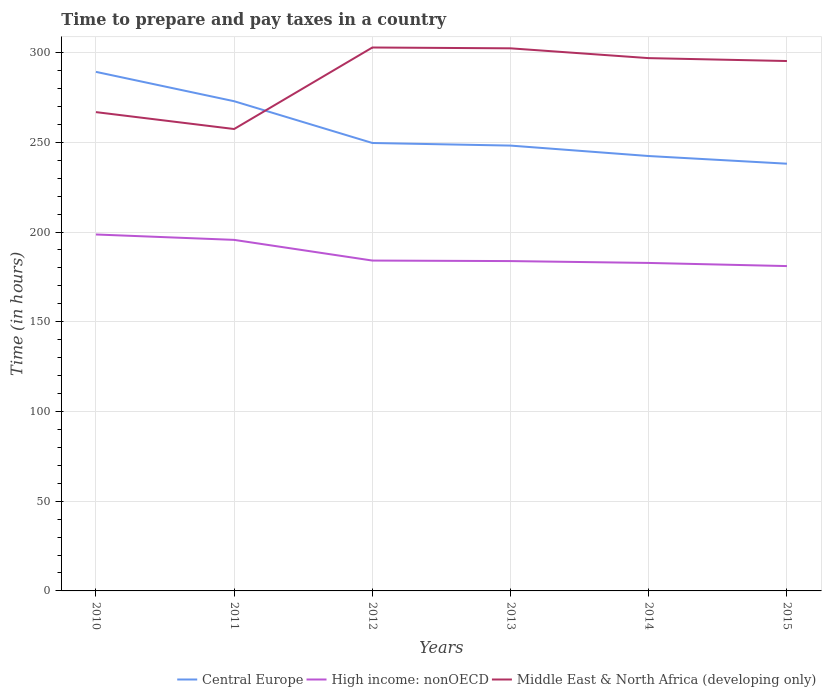How many different coloured lines are there?
Offer a terse response. 3. Across all years, what is the maximum number of hours required to prepare and pay taxes in Central Europe?
Make the answer very short. 238.09. In which year was the number of hours required to prepare and pay taxes in High income: nonOECD maximum?
Your response must be concise. 2015. What is the total number of hours required to prepare and pay taxes in Central Europe in the graph?
Ensure brevity in your answer.  51.18. What is the difference between the highest and the second highest number of hours required to prepare and pay taxes in Middle East & North Africa (developing only)?
Your answer should be compact. 45.43. What is the difference between the highest and the lowest number of hours required to prepare and pay taxes in Central Europe?
Provide a short and direct response. 2. Is the number of hours required to prepare and pay taxes in Central Europe strictly greater than the number of hours required to prepare and pay taxes in Middle East & North Africa (developing only) over the years?
Give a very brief answer. No. Are the values on the major ticks of Y-axis written in scientific E-notation?
Keep it short and to the point. No. Does the graph contain any zero values?
Provide a succinct answer. No. Does the graph contain grids?
Your answer should be compact. Yes. How many legend labels are there?
Make the answer very short. 3. What is the title of the graph?
Keep it short and to the point. Time to prepare and pay taxes in a country. What is the label or title of the Y-axis?
Keep it short and to the point. Time (in hours). What is the Time (in hours) of Central Europe in 2010?
Keep it short and to the point. 289.27. What is the Time (in hours) of High income: nonOECD in 2010?
Offer a terse response. 198.65. What is the Time (in hours) in Middle East & North Africa (developing only) in 2010?
Your response must be concise. 266.83. What is the Time (in hours) in Central Europe in 2011?
Your response must be concise. 272.91. What is the Time (in hours) in High income: nonOECD in 2011?
Ensure brevity in your answer.  195.63. What is the Time (in hours) of Middle East & North Africa (developing only) in 2011?
Offer a terse response. 257.42. What is the Time (in hours) of Central Europe in 2012?
Ensure brevity in your answer.  249.64. What is the Time (in hours) of High income: nonOECD in 2012?
Your answer should be compact. 184.11. What is the Time (in hours) in Middle East & North Africa (developing only) in 2012?
Ensure brevity in your answer.  302.85. What is the Time (in hours) in Central Europe in 2013?
Make the answer very short. 248.18. What is the Time (in hours) in High income: nonOECD in 2013?
Offer a very short reply. 183.82. What is the Time (in hours) in Middle East & North Africa (developing only) in 2013?
Your response must be concise. 302.38. What is the Time (in hours) of Central Europe in 2014?
Ensure brevity in your answer.  242.36. What is the Time (in hours) of High income: nonOECD in 2014?
Ensure brevity in your answer.  182.79. What is the Time (in hours) in Middle East & North Africa (developing only) in 2014?
Ensure brevity in your answer.  296.92. What is the Time (in hours) of Central Europe in 2015?
Your answer should be compact. 238.09. What is the Time (in hours) of High income: nonOECD in 2015?
Give a very brief answer. 181.04. What is the Time (in hours) of Middle East & North Africa (developing only) in 2015?
Offer a very short reply. 295.31. Across all years, what is the maximum Time (in hours) of Central Europe?
Give a very brief answer. 289.27. Across all years, what is the maximum Time (in hours) of High income: nonOECD?
Give a very brief answer. 198.65. Across all years, what is the maximum Time (in hours) in Middle East & North Africa (developing only)?
Your answer should be very brief. 302.85. Across all years, what is the minimum Time (in hours) of Central Europe?
Give a very brief answer. 238.09. Across all years, what is the minimum Time (in hours) of High income: nonOECD?
Your response must be concise. 181.04. Across all years, what is the minimum Time (in hours) in Middle East & North Africa (developing only)?
Make the answer very short. 257.42. What is the total Time (in hours) of Central Europe in the graph?
Offer a terse response. 1540.45. What is the total Time (in hours) of High income: nonOECD in the graph?
Provide a short and direct response. 1126.03. What is the total Time (in hours) in Middle East & North Africa (developing only) in the graph?
Keep it short and to the point. 1721.71. What is the difference between the Time (in hours) in Central Europe in 2010 and that in 2011?
Ensure brevity in your answer.  16.36. What is the difference between the Time (in hours) in High income: nonOECD in 2010 and that in 2011?
Offer a terse response. 3.01. What is the difference between the Time (in hours) in Middle East & North Africa (developing only) in 2010 and that in 2011?
Ensure brevity in your answer.  9.42. What is the difference between the Time (in hours) in Central Europe in 2010 and that in 2012?
Offer a very short reply. 39.64. What is the difference between the Time (in hours) in High income: nonOECD in 2010 and that in 2012?
Ensure brevity in your answer.  14.53. What is the difference between the Time (in hours) of Middle East & North Africa (developing only) in 2010 and that in 2012?
Your answer should be compact. -36.01. What is the difference between the Time (in hours) in Central Europe in 2010 and that in 2013?
Give a very brief answer. 41.09. What is the difference between the Time (in hours) in High income: nonOECD in 2010 and that in 2013?
Offer a terse response. 14.82. What is the difference between the Time (in hours) in Middle East & North Africa (developing only) in 2010 and that in 2013?
Ensure brevity in your answer.  -35.55. What is the difference between the Time (in hours) of Central Europe in 2010 and that in 2014?
Make the answer very short. 46.91. What is the difference between the Time (in hours) in High income: nonOECD in 2010 and that in 2014?
Offer a terse response. 15.86. What is the difference between the Time (in hours) in Middle East & North Africa (developing only) in 2010 and that in 2014?
Your answer should be very brief. -30.09. What is the difference between the Time (in hours) in Central Europe in 2010 and that in 2015?
Offer a terse response. 51.18. What is the difference between the Time (in hours) of High income: nonOECD in 2010 and that in 2015?
Your answer should be very brief. 17.61. What is the difference between the Time (in hours) in Middle East & North Africa (developing only) in 2010 and that in 2015?
Make the answer very short. -28.47. What is the difference between the Time (in hours) in Central Europe in 2011 and that in 2012?
Ensure brevity in your answer.  23.27. What is the difference between the Time (in hours) in High income: nonOECD in 2011 and that in 2012?
Offer a very short reply. 11.52. What is the difference between the Time (in hours) of Middle East & North Africa (developing only) in 2011 and that in 2012?
Provide a succinct answer. -45.43. What is the difference between the Time (in hours) in Central Europe in 2011 and that in 2013?
Your answer should be very brief. 24.73. What is the difference between the Time (in hours) of High income: nonOECD in 2011 and that in 2013?
Make the answer very short. 11.81. What is the difference between the Time (in hours) of Middle East & North Africa (developing only) in 2011 and that in 2013?
Provide a short and direct response. -44.97. What is the difference between the Time (in hours) of Central Europe in 2011 and that in 2014?
Offer a terse response. 30.55. What is the difference between the Time (in hours) in High income: nonOECD in 2011 and that in 2014?
Your answer should be compact. 12.85. What is the difference between the Time (in hours) of Middle East & North Africa (developing only) in 2011 and that in 2014?
Offer a very short reply. -39.51. What is the difference between the Time (in hours) of Central Europe in 2011 and that in 2015?
Make the answer very short. 34.82. What is the difference between the Time (in hours) in High income: nonOECD in 2011 and that in 2015?
Keep it short and to the point. 14.6. What is the difference between the Time (in hours) in Middle East & North Africa (developing only) in 2011 and that in 2015?
Your response must be concise. -37.89. What is the difference between the Time (in hours) of Central Europe in 2012 and that in 2013?
Ensure brevity in your answer.  1.45. What is the difference between the Time (in hours) in High income: nonOECD in 2012 and that in 2013?
Offer a terse response. 0.29. What is the difference between the Time (in hours) of Middle East & North Africa (developing only) in 2012 and that in 2013?
Provide a short and direct response. 0.46. What is the difference between the Time (in hours) in Central Europe in 2012 and that in 2014?
Give a very brief answer. 7.27. What is the difference between the Time (in hours) of High income: nonOECD in 2012 and that in 2014?
Keep it short and to the point. 1.33. What is the difference between the Time (in hours) of Middle East & North Africa (developing only) in 2012 and that in 2014?
Provide a succinct answer. 5.92. What is the difference between the Time (in hours) in Central Europe in 2012 and that in 2015?
Your answer should be very brief. 11.55. What is the difference between the Time (in hours) in High income: nonOECD in 2012 and that in 2015?
Provide a short and direct response. 3.08. What is the difference between the Time (in hours) in Middle East & North Africa (developing only) in 2012 and that in 2015?
Offer a very short reply. 7.54. What is the difference between the Time (in hours) of Central Europe in 2013 and that in 2014?
Provide a short and direct response. 5.82. What is the difference between the Time (in hours) of High income: nonOECD in 2013 and that in 2014?
Offer a terse response. 1.04. What is the difference between the Time (in hours) of Middle East & North Africa (developing only) in 2013 and that in 2014?
Keep it short and to the point. 5.46. What is the difference between the Time (in hours) in Central Europe in 2013 and that in 2015?
Your response must be concise. 10.09. What is the difference between the Time (in hours) of High income: nonOECD in 2013 and that in 2015?
Your answer should be very brief. 2.79. What is the difference between the Time (in hours) in Middle East & North Africa (developing only) in 2013 and that in 2015?
Keep it short and to the point. 7.08. What is the difference between the Time (in hours) in Central Europe in 2014 and that in 2015?
Offer a very short reply. 4.27. What is the difference between the Time (in hours) of Middle East & North Africa (developing only) in 2014 and that in 2015?
Give a very brief answer. 1.62. What is the difference between the Time (in hours) of Central Europe in 2010 and the Time (in hours) of High income: nonOECD in 2011?
Give a very brief answer. 93.64. What is the difference between the Time (in hours) of Central Europe in 2010 and the Time (in hours) of Middle East & North Africa (developing only) in 2011?
Offer a terse response. 31.86. What is the difference between the Time (in hours) in High income: nonOECD in 2010 and the Time (in hours) in Middle East & North Africa (developing only) in 2011?
Offer a very short reply. -58.77. What is the difference between the Time (in hours) in Central Europe in 2010 and the Time (in hours) in High income: nonOECD in 2012?
Offer a terse response. 105.16. What is the difference between the Time (in hours) of Central Europe in 2010 and the Time (in hours) of Middle East & North Africa (developing only) in 2012?
Give a very brief answer. -13.57. What is the difference between the Time (in hours) in High income: nonOECD in 2010 and the Time (in hours) in Middle East & North Africa (developing only) in 2012?
Provide a short and direct response. -104.2. What is the difference between the Time (in hours) of Central Europe in 2010 and the Time (in hours) of High income: nonOECD in 2013?
Your answer should be very brief. 105.45. What is the difference between the Time (in hours) of Central Europe in 2010 and the Time (in hours) of Middle East & North Africa (developing only) in 2013?
Ensure brevity in your answer.  -13.11. What is the difference between the Time (in hours) of High income: nonOECD in 2010 and the Time (in hours) of Middle East & North Africa (developing only) in 2013?
Your response must be concise. -103.74. What is the difference between the Time (in hours) of Central Europe in 2010 and the Time (in hours) of High income: nonOECD in 2014?
Your response must be concise. 106.49. What is the difference between the Time (in hours) of Central Europe in 2010 and the Time (in hours) of Middle East & North Africa (developing only) in 2014?
Offer a terse response. -7.65. What is the difference between the Time (in hours) of High income: nonOECD in 2010 and the Time (in hours) of Middle East & North Africa (developing only) in 2014?
Give a very brief answer. -98.28. What is the difference between the Time (in hours) of Central Europe in 2010 and the Time (in hours) of High income: nonOECD in 2015?
Offer a terse response. 108.24. What is the difference between the Time (in hours) of Central Europe in 2010 and the Time (in hours) of Middle East & North Africa (developing only) in 2015?
Your response must be concise. -6.04. What is the difference between the Time (in hours) of High income: nonOECD in 2010 and the Time (in hours) of Middle East & North Africa (developing only) in 2015?
Your answer should be compact. -96.66. What is the difference between the Time (in hours) of Central Europe in 2011 and the Time (in hours) of High income: nonOECD in 2012?
Offer a very short reply. 88.8. What is the difference between the Time (in hours) of Central Europe in 2011 and the Time (in hours) of Middle East & North Africa (developing only) in 2012?
Your answer should be compact. -29.94. What is the difference between the Time (in hours) of High income: nonOECD in 2011 and the Time (in hours) of Middle East & North Africa (developing only) in 2012?
Give a very brief answer. -107.21. What is the difference between the Time (in hours) of Central Europe in 2011 and the Time (in hours) of High income: nonOECD in 2013?
Offer a very short reply. 89.09. What is the difference between the Time (in hours) of Central Europe in 2011 and the Time (in hours) of Middle East & North Africa (developing only) in 2013?
Your answer should be compact. -29.48. What is the difference between the Time (in hours) of High income: nonOECD in 2011 and the Time (in hours) of Middle East & North Africa (developing only) in 2013?
Provide a short and direct response. -106.75. What is the difference between the Time (in hours) in Central Europe in 2011 and the Time (in hours) in High income: nonOECD in 2014?
Your answer should be very brief. 90.12. What is the difference between the Time (in hours) of Central Europe in 2011 and the Time (in hours) of Middle East & North Africa (developing only) in 2014?
Provide a short and direct response. -24.01. What is the difference between the Time (in hours) in High income: nonOECD in 2011 and the Time (in hours) in Middle East & North Africa (developing only) in 2014?
Keep it short and to the point. -101.29. What is the difference between the Time (in hours) in Central Europe in 2011 and the Time (in hours) in High income: nonOECD in 2015?
Keep it short and to the point. 91.87. What is the difference between the Time (in hours) in Central Europe in 2011 and the Time (in hours) in Middle East & North Africa (developing only) in 2015?
Give a very brief answer. -22.4. What is the difference between the Time (in hours) of High income: nonOECD in 2011 and the Time (in hours) of Middle East & North Africa (developing only) in 2015?
Your response must be concise. -99.67. What is the difference between the Time (in hours) in Central Europe in 2012 and the Time (in hours) in High income: nonOECD in 2013?
Offer a terse response. 65.81. What is the difference between the Time (in hours) of Central Europe in 2012 and the Time (in hours) of Middle East & North Africa (developing only) in 2013?
Your answer should be very brief. -52.75. What is the difference between the Time (in hours) of High income: nonOECD in 2012 and the Time (in hours) of Middle East & North Africa (developing only) in 2013?
Offer a terse response. -118.27. What is the difference between the Time (in hours) of Central Europe in 2012 and the Time (in hours) of High income: nonOECD in 2014?
Your answer should be very brief. 66.85. What is the difference between the Time (in hours) in Central Europe in 2012 and the Time (in hours) in Middle East & North Africa (developing only) in 2014?
Make the answer very short. -47.29. What is the difference between the Time (in hours) of High income: nonOECD in 2012 and the Time (in hours) of Middle East & North Africa (developing only) in 2014?
Provide a short and direct response. -112.81. What is the difference between the Time (in hours) in Central Europe in 2012 and the Time (in hours) in High income: nonOECD in 2015?
Ensure brevity in your answer.  68.6. What is the difference between the Time (in hours) of Central Europe in 2012 and the Time (in hours) of Middle East & North Africa (developing only) in 2015?
Provide a succinct answer. -45.67. What is the difference between the Time (in hours) in High income: nonOECD in 2012 and the Time (in hours) in Middle East & North Africa (developing only) in 2015?
Give a very brief answer. -111.2. What is the difference between the Time (in hours) in Central Europe in 2013 and the Time (in hours) in High income: nonOECD in 2014?
Your answer should be very brief. 65.4. What is the difference between the Time (in hours) of Central Europe in 2013 and the Time (in hours) of Middle East & North Africa (developing only) in 2014?
Offer a very short reply. -48.74. What is the difference between the Time (in hours) in High income: nonOECD in 2013 and the Time (in hours) in Middle East & North Africa (developing only) in 2014?
Provide a succinct answer. -113.1. What is the difference between the Time (in hours) in Central Europe in 2013 and the Time (in hours) in High income: nonOECD in 2015?
Ensure brevity in your answer.  67.15. What is the difference between the Time (in hours) in Central Europe in 2013 and the Time (in hours) in Middle East & North Africa (developing only) in 2015?
Ensure brevity in your answer.  -47.13. What is the difference between the Time (in hours) of High income: nonOECD in 2013 and the Time (in hours) of Middle East & North Africa (developing only) in 2015?
Keep it short and to the point. -111.49. What is the difference between the Time (in hours) of Central Europe in 2014 and the Time (in hours) of High income: nonOECD in 2015?
Give a very brief answer. 61.33. What is the difference between the Time (in hours) in Central Europe in 2014 and the Time (in hours) in Middle East & North Africa (developing only) in 2015?
Your answer should be compact. -52.94. What is the difference between the Time (in hours) of High income: nonOECD in 2014 and the Time (in hours) of Middle East & North Africa (developing only) in 2015?
Offer a very short reply. -112.52. What is the average Time (in hours) of Central Europe per year?
Offer a terse response. 256.74. What is the average Time (in hours) in High income: nonOECD per year?
Give a very brief answer. 187.67. What is the average Time (in hours) in Middle East & North Africa (developing only) per year?
Your answer should be compact. 286.95. In the year 2010, what is the difference between the Time (in hours) in Central Europe and Time (in hours) in High income: nonOECD?
Keep it short and to the point. 90.63. In the year 2010, what is the difference between the Time (in hours) of Central Europe and Time (in hours) of Middle East & North Africa (developing only)?
Your answer should be very brief. 22.44. In the year 2010, what is the difference between the Time (in hours) of High income: nonOECD and Time (in hours) of Middle East & North Africa (developing only)?
Provide a succinct answer. -68.19. In the year 2011, what is the difference between the Time (in hours) of Central Europe and Time (in hours) of High income: nonOECD?
Offer a very short reply. 77.27. In the year 2011, what is the difference between the Time (in hours) in Central Europe and Time (in hours) in Middle East & North Africa (developing only)?
Your response must be concise. 15.49. In the year 2011, what is the difference between the Time (in hours) in High income: nonOECD and Time (in hours) in Middle East & North Africa (developing only)?
Ensure brevity in your answer.  -61.78. In the year 2012, what is the difference between the Time (in hours) in Central Europe and Time (in hours) in High income: nonOECD?
Keep it short and to the point. 65.53. In the year 2012, what is the difference between the Time (in hours) of Central Europe and Time (in hours) of Middle East & North Africa (developing only)?
Your answer should be compact. -53.21. In the year 2012, what is the difference between the Time (in hours) of High income: nonOECD and Time (in hours) of Middle East & North Africa (developing only)?
Your answer should be very brief. -118.73. In the year 2013, what is the difference between the Time (in hours) of Central Europe and Time (in hours) of High income: nonOECD?
Your answer should be compact. 64.36. In the year 2013, what is the difference between the Time (in hours) of Central Europe and Time (in hours) of Middle East & North Africa (developing only)?
Your response must be concise. -54.2. In the year 2013, what is the difference between the Time (in hours) in High income: nonOECD and Time (in hours) in Middle East & North Africa (developing only)?
Ensure brevity in your answer.  -118.56. In the year 2014, what is the difference between the Time (in hours) in Central Europe and Time (in hours) in High income: nonOECD?
Provide a short and direct response. 59.58. In the year 2014, what is the difference between the Time (in hours) in Central Europe and Time (in hours) in Middle East & North Africa (developing only)?
Your answer should be very brief. -54.56. In the year 2014, what is the difference between the Time (in hours) in High income: nonOECD and Time (in hours) in Middle East & North Africa (developing only)?
Make the answer very short. -114.14. In the year 2015, what is the difference between the Time (in hours) in Central Europe and Time (in hours) in High income: nonOECD?
Your answer should be very brief. 57.06. In the year 2015, what is the difference between the Time (in hours) in Central Europe and Time (in hours) in Middle East & North Africa (developing only)?
Give a very brief answer. -57.22. In the year 2015, what is the difference between the Time (in hours) in High income: nonOECD and Time (in hours) in Middle East & North Africa (developing only)?
Give a very brief answer. -114.27. What is the ratio of the Time (in hours) of Central Europe in 2010 to that in 2011?
Give a very brief answer. 1.06. What is the ratio of the Time (in hours) of High income: nonOECD in 2010 to that in 2011?
Your answer should be very brief. 1.02. What is the ratio of the Time (in hours) in Middle East & North Africa (developing only) in 2010 to that in 2011?
Your answer should be very brief. 1.04. What is the ratio of the Time (in hours) in Central Europe in 2010 to that in 2012?
Your answer should be very brief. 1.16. What is the ratio of the Time (in hours) of High income: nonOECD in 2010 to that in 2012?
Provide a short and direct response. 1.08. What is the ratio of the Time (in hours) in Middle East & North Africa (developing only) in 2010 to that in 2012?
Provide a short and direct response. 0.88. What is the ratio of the Time (in hours) in Central Europe in 2010 to that in 2013?
Your response must be concise. 1.17. What is the ratio of the Time (in hours) in High income: nonOECD in 2010 to that in 2013?
Your answer should be compact. 1.08. What is the ratio of the Time (in hours) of Middle East & North Africa (developing only) in 2010 to that in 2013?
Keep it short and to the point. 0.88. What is the ratio of the Time (in hours) in Central Europe in 2010 to that in 2014?
Provide a succinct answer. 1.19. What is the ratio of the Time (in hours) in High income: nonOECD in 2010 to that in 2014?
Your answer should be compact. 1.09. What is the ratio of the Time (in hours) in Middle East & North Africa (developing only) in 2010 to that in 2014?
Keep it short and to the point. 0.9. What is the ratio of the Time (in hours) in Central Europe in 2010 to that in 2015?
Ensure brevity in your answer.  1.22. What is the ratio of the Time (in hours) of High income: nonOECD in 2010 to that in 2015?
Give a very brief answer. 1.1. What is the ratio of the Time (in hours) in Middle East & North Africa (developing only) in 2010 to that in 2015?
Offer a terse response. 0.9. What is the ratio of the Time (in hours) in Central Europe in 2011 to that in 2012?
Give a very brief answer. 1.09. What is the ratio of the Time (in hours) in High income: nonOECD in 2011 to that in 2012?
Your answer should be very brief. 1.06. What is the ratio of the Time (in hours) of Middle East & North Africa (developing only) in 2011 to that in 2012?
Your answer should be very brief. 0.85. What is the ratio of the Time (in hours) of Central Europe in 2011 to that in 2013?
Make the answer very short. 1.1. What is the ratio of the Time (in hours) in High income: nonOECD in 2011 to that in 2013?
Give a very brief answer. 1.06. What is the ratio of the Time (in hours) in Middle East & North Africa (developing only) in 2011 to that in 2013?
Ensure brevity in your answer.  0.85. What is the ratio of the Time (in hours) of Central Europe in 2011 to that in 2014?
Ensure brevity in your answer.  1.13. What is the ratio of the Time (in hours) of High income: nonOECD in 2011 to that in 2014?
Your response must be concise. 1.07. What is the ratio of the Time (in hours) in Middle East & North Africa (developing only) in 2011 to that in 2014?
Make the answer very short. 0.87. What is the ratio of the Time (in hours) of Central Europe in 2011 to that in 2015?
Provide a succinct answer. 1.15. What is the ratio of the Time (in hours) in High income: nonOECD in 2011 to that in 2015?
Provide a short and direct response. 1.08. What is the ratio of the Time (in hours) of Middle East & North Africa (developing only) in 2011 to that in 2015?
Keep it short and to the point. 0.87. What is the ratio of the Time (in hours) in Central Europe in 2012 to that in 2013?
Provide a short and direct response. 1.01. What is the ratio of the Time (in hours) in High income: nonOECD in 2012 to that in 2013?
Your response must be concise. 1. What is the ratio of the Time (in hours) of High income: nonOECD in 2012 to that in 2014?
Offer a terse response. 1.01. What is the ratio of the Time (in hours) in Middle East & North Africa (developing only) in 2012 to that in 2014?
Your response must be concise. 1.02. What is the ratio of the Time (in hours) in Central Europe in 2012 to that in 2015?
Your answer should be very brief. 1.05. What is the ratio of the Time (in hours) of High income: nonOECD in 2012 to that in 2015?
Provide a succinct answer. 1.02. What is the ratio of the Time (in hours) in Middle East & North Africa (developing only) in 2012 to that in 2015?
Ensure brevity in your answer.  1.03. What is the ratio of the Time (in hours) in Central Europe in 2013 to that in 2014?
Ensure brevity in your answer.  1.02. What is the ratio of the Time (in hours) in High income: nonOECD in 2013 to that in 2014?
Keep it short and to the point. 1.01. What is the ratio of the Time (in hours) of Middle East & North Africa (developing only) in 2013 to that in 2014?
Offer a terse response. 1.02. What is the ratio of the Time (in hours) in Central Europe in 2013 to that in 2015?
Ensure brevity in your answer.  1.04. What is the ratio of the Time (in hours) of High income: nonOECD in 2013 to that in 2015?
Ensure brevity in your answer.  1.02. What is the ratio of the Time (in hours) in Middle East & North Africa (developing only) in 2013 to that in 2015?
Ensure brevity in your answer.  1.02. What is the ratio of the Time (in hours) of Central Europe in 2014 to that in 2015?
Your answer should be very brief. 1.02. What is the ratio of the Time (in hours) in High income: nonOECD in 2014 to that in 2015?
Your answer should be very brief. 1.01. What is the ratio of the Time (in hours) in Middle East & North Africa (developing only) in 2014 to that in 2015?
Offer a very short reply. 1.01. What is the difference between the highest and the second highest Time (in hours) in Central Europe?
Your answer should be very brief. 16.36. What is the difference between the highest and the second highest Time (in hours) of High income: nonOECD?
Ensure brevity in your answer.  3.01. What is the difference between the highest and the second highest Time (in hours) in Middle East & North Africa (developing only)?
Offer a terse response. 0.46. What is the difference between the highest and the lowest Time (in hours) in Central Europe?
Provide a short and direct response. 51.18. What is the difference between the highest and the lowest Time (in hours) of High income: nonOECD?
Provide a succinct answer. 17.61. What is the difference between the highest and the lowest Time (in hours) in Middle East & North Africa (developing only)?
Give a very brief answer. 45.43. 